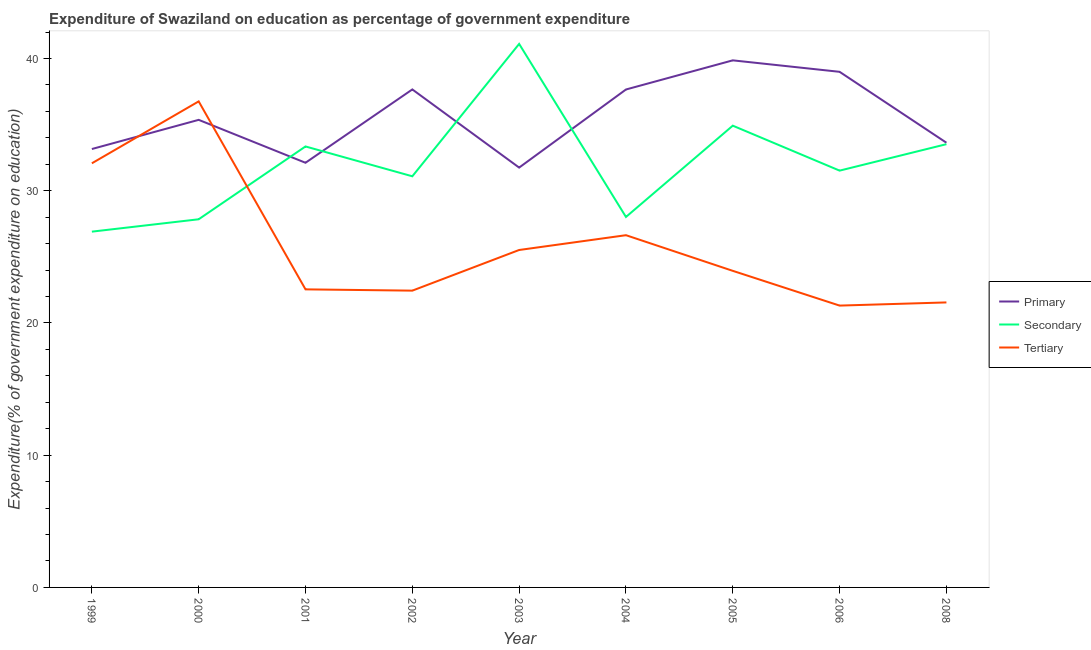What is the expenditure on secondary education in 2008?
Provide a short and direct response. 33.52. Across all years, what is the maximum expenditure on primary education?
Keep it short and to the point. 39.86. Across all years, what is the minimum expenditure on secondary education?
Your answer should be very brief. 26.9. In which year was the expenditure on tertiary education maximum?
Give a very brief answer. 2000. What is the total expenditure on primary education in the graph?
Your answer should be compact. 320.17. What is the difference between the expenditure on primary education in 2000 and that in 2005?
Provide a succinct answer. -4.5. What is the difference between the expenditure on tertiary education in 2008 and the expenditure on primary education in 2006?
Provide a succinct answer. -17.44. What is the average expenditure on secondary education per year?
Offer a very short reply. 32.03. In the year 1999, what is the difference between the expenditure on tertiary education and expenditure on secondary education?
Make the answer very short. 5.17. What is the ratio of the expenditure on secondary education in 2000 to that in 2006?
Offer a terse response. 0.88. What is the difference between the highest and the second highest expenditure on primary education?
Your answer should be compact. 0.87. What is the difference between the highest and the lowest expenditure on primary education?
Offer a terse response. 8.11. In how many years, is the expenditure on tertiary education greater than the average expenditure on tertiary education taken over all years?
Provide a short and direct response. 3. Is the sum of the expenditure on secondary education in 2005 and 2008 greater than the maximum expenditure on tertiary education across all years?
Make the answer very short. Yes. Does the expenditure on primary education monotonically increase over the years?
Your answer should be very brief. No. Is the expenditure on secondary education strictly less than the expenditure on primary education over the years?
Your answer should be very brief. No. How many years are there in the graph?
Keep it short and to the point. 9. Does the graph contain any zero values?
Provide a succinct answer. No. Does the graph contain grids?
Give a very brief answer. No. Where does the legend appear in the graph?
Give a very brief answer. Center right. How many legend labels are there?
Offer a terse response. 3. What is the title of the graph?
Your answer should be very brief. Expenditure of Swaziland on education as percentage of government expenditure. Does "Errors" appear as one of the legend labels in the graph?
Provide a short and direct response. No. What is the label or title of the Y-axis?
Offer a terse response. Expenditure(% of government expenditure on education). What is the Expenditure(% of government expenditure on education) in Primary in 1999?
Your answer should be very brief. 33.15. What is the Expenditure(% of government expenditure on education) of Secondary in 1999?
Make the answer very short. 26.9. What is the Expenditure(% of government expenditure on education) of Tertiary in 1999?
Provide a succinct answer. 32.07. What is the Expenditure(% of government expenditure on education) in Primary in 2000?
Your answer should be compact. 35.36. What is the Expenditure(% of government expenditure on education) in Secondary in 2000?
Your answer should be very brief. 27.84. What is the Expenditure(% of government expenditure on education) in Tertiary in 2000?
Offer a terse response. 36.76. What is the Expenditure(% of government expenditure on education) in Primary in 2001?
Your answer should be very brief. 32.11. What is the Expenditure(% of government expenditure on education) in Secondary in 2001?
Offer a very short reply. 33.35. What is the Expenditure(% of government expenditure on education) in Tertiary in 2001?
Provide a succinct answer. 22.54. What is the Expenditure(% of government expenditure on education) in Primary in 2002?
Your response must be concise. 37.66. What is the Expenditure(% of government expenditure on education) in Secondary in 2002?
Make the answer very short. 31.09. What is the Expenditure(% of government expenditure on education) in Tertiary in 2002?
Provide a short and direct response. 22.44. What is the Expenditure(% of government expenditure on education) in Primary in 2003?
Your response must be concise. 31.75. What is the Expenditure(% of government expenditure on education) of Secondary in 2003?
Offer a very short reply. 41.1. What is the Expenditure(% of government expenditure on education) of Tertiary in 2003?
Give a very brief answer. 25.52. What is the Expenditure(% of government expenditure on education) in Primary in 2004?
Provide a succinct answer. 37.66. What is the Expenditure(% of government expenditure on education) in Secondary in 2004?
Ensure brevity in your answer.  28.02. What is the Expenditure(% of government expenditure on education) of Tertiary in 2004?
Your answer should be very brief. 26.64. What is the Expenditure(% of government expenditure on education) in Primary in 2005?
Give a very brief answer. 39.86. What is the Expenditure(% of government expenditure on education) of Secondary in 2005?
Your answer should be very brief. 34.92. What is the Expenditure(% of government expenditure on education) of Tertiary in 2005?
Provide a short and direct response. 23.94. What is the Expenditure(% of government expenditure on education) of Primary in 2006?
Your answer should be compact. 38.99. What is the Expenditure(% of government expenditure on education) of Secondary in 2006?
Offer a very short reply. 31.52. What is the Expenditure(% of government expenditure on education) of Tertiary in 2006?
Provide a short and direct response. 21.31. What is the Expenditure(% of government expenditure on education) of Primary in 2008?
Give a very brief answer. 33.63. What is the Expenditure(% of government expenditure on education) of Secondary in 2008?
Offer a very short reply. 33.52. What is the Expenditure(% of government expenditure on education) in Tertiary in 2008?
Give a very brief answer. 21.55. Across all years, what is the maximum Expenditure(% of government expenditure on education) in Primary?
Your answer should be compact. 39.86. Across all years, what is the maximum Expenditure(% of government expenditure on education) of Secondary?
Keep it short and to the point. 41.1. Across all years, what is the maximum Expenditure(% of government expenditure on education) of Tertiary?
Give a very brief answer. 36.76. Across all years, what is the minimum Expenditure(% of government expenditure on education) of Primary?
Ensure brevity in your answer.  31.75. Across all years, what is the minimum Expenditure(% of government expenditure on education) in Secondary?
Ensure brevity in your answer.  26.9. Across all years, what is the minimum Expenditure(% of government expenditure on education) of Tertiary?
Offer a terse response. 21.31. What is the total Expenditure(% of government expenditure on education) of Primary in the graph?
Provide a succinct answer. 320.17. What is the total Expenditure(% of government expenditure on education) in Secondary in the graph?
Offer a very short reply. 288.26. What is the total Expenditure(% of government expenditure on education) of Tertiary in the graph?
Offer a very short reply. 232.77. What is the difference between the Expenditure(% of government expenditure on education) in Primary in 1999 and that in 2000?
Ensure brevity in your answer.  -2.21. What is the difference between the Expenditure(% of government expenditure on education) of Secondary in 1999 and that in 2000?
Your response must be concise. -0.94. What is the difference between the Expenditure(% of government expenditure on education) of Tertiary in 1999 and that in 2000?
Keep it short and to the point. -4.68. What is the difference between the Expenditure(% of government expenditure on education) of Primary in 1999 and that in 2001?
Keep it short and to the point. 1.04. What is the difference between the Expenditure(% of government expenditure on education) of Secondary in 1999 and that in 2001?
Keep it short and to the point. -6.44. What is the difference between the Expenditure(% of government expenditure on education) in Tertiary in 1999 and that in 2001?
Keep it short and to the point. 9.53. What is the difference between the Expenditure(% of government expenditure on education) of Primary in 1999 and that in 2002?
Provide a short and direct response. -4.51. What is the difference between the Expenditure(% of government expenditure on education) in Secondary in 1999 and that in 2002?
Give a very brief answer. -4.19. What is the difference between the Expenditure(% of government expenditure on education) in Tertiary in 1999 and that in 2002?
Give a very brief answer. 9.63. What is the difference between the Expenditure(% of government expenditure on education) of Primary in 1999 and that in 2003?
Your response must be concise. 1.4. What is the difference between the Expenditure(% of government expenditure on education) of Secondary in 1999 and that in 2003?
Ensure brevity in your answer.  -14.2. What is the difference between the Expenditure(% of government expenditure on education) of Tertiary in 1999 and that in 2003?
Give a very brief answer. 6.56. What is the difference between the Expenditure(% of government expenditure on education) in Primary in 1999 and that in 2004?
Make the answer very short. -4.5. What is the difference between the Expenditure(% of government expenditure on education) in Secondary in 1999 and that in 2004?
Offer a very short reply. -1.11. What is the difference between the Expenditure(% of government expenditure on education) in Tertiary in 1999 and that in 2004?
Give a very brief answer. 5.44. What is the difference between the Expenditure(% of government expenditure on education) of Primary in 1999 and that in 2005?
Your answer should be compact. -6.71. What is the difference between the Expenditure(% of government expenditure on education) of Secondary in 1999 and that in 2005?
Provide a succinct answer. -8.02. What is the difference between the Expenditure(% of government expenditure on education) of Tertiary in 1999 and that in 2005?
Provide a succinct answer. 8.13. What is the difference between the Expenditure(% of government expenditure on education) in Primary in 1999 and that in 2006?
Make the answer very short. -5.84. What is the difference between the Expenditure(% of government expenditure on education) in Secondary in 1999 and that in 2006?
Provide a short and direct response. -4.61. What is the difference between the Expenditure(% of government expenditure on education) of Tertiary in 1999 and that in 2006?
Give a very brief answer. 10.76. What is the difference between the Expenditure(% of government expenditure on education) in Primary in 1999 and that in 2008?
Provide a short and direct response. -0.48. What is the difference between the Expenditure(% of government expenditure on education) in Secondary in 1999 and that in 2008?
Your answer should be compact. -6.62. What is the difference between the Expenditure(% of government expenditure on education) in Tertiary in 1999 and that in 2008?
Ensure brevity in your answer.  10.52. What is the difference between the Expenditure(% of government expenditure on education) in Primary in 2000 and that in 2001?
Keep it short and to the point. 3.25. What is the difference between the Expenditure(% of government expenditure on education) in Secondary in 2000 and that in 2001?
Your answer should be compact. -5.51. What is the difference between the Expenditure(% of government expenditure on education) of Tertiary in 2000 and that in 2001?
Your answer should be compact. 14.21. What is the difference between the Expenditure(% of government expenditure on education) in Primary in 2000 and that in 2002?
Your response must be concise. -2.3. What is the difference between the Expenditure(% of government expenditure on education) of Secondary in 2000 and that in 2002?
Your response must be concise. -3.25. What is the difference between the Expenditure(% of government expenditure on education) in Tertiary in 2000 and that in 2002?
Your answer should be very brief. 14.31. What is the difference between the Expenditure(% of government expenditure on education) in Primary in 2000 and that in 2003?
Ensure brevity in your answer.  3.61. What is the difference between the Expenditure(% of government expenditure on education) in Secondary in 2000 and that in 2003?
Your answer should be very brief. -13.26. What is the difference between the Expenditure(% of government expenditure on education) of Tertiary in 2000 and that in 2003?
Offer a very short reply. 11.24. What is the difference between the Expenditure(% of government expenditure on education) in Primary in 2000 and that in 2004?
Your answer should be compact. -2.3. What is the difference between the Expenditure(% of government expenditure on education) of Secondary in 2000 and that in 2004?
Give a very brief answer. -0.17. What is the difference between the Expenditure(% of government expenditure on education) of Tertiary in 2000 and that in 2004?
Keep it short and to the point. 10.12. What is the difference between the Expenditure(% of government expenditure on education) of Secondary in 2000 and that in 2005?
Your answer should be very brief. -7.08. What is the difference between the Expenditure(% of government expenditure on education) of Tertiary in 2000 and that in 2005?
Make the answer very short. 12.82. What is the difference between the Expenditure(% of government expenditure on education) of Primary in 2000 and that in 2006?
Provide a succinct answer. -3.63. What is the difference between the Expenditure(% of government expenditure on education) in Secondary in 2000 and that in 2006?
Ensure brevity in your answer.  -3.68. What is the difference between the Expenditure(% of government expenditure on education) of Tertiary in 2000 and that in 2006?
Offer a terse response. 15.44. What is the difference between the Expenditure(% of government expenditure on education) of Primary in 2000 and that in 2008?
Offer a very short reply. 1.73. What is the difference between the Expenditure(% of government expenditure on education) in Secondary in 2000 and that in 2008?
Provide a succinct answer. -5.68. What is the difference between the Expenditure(% of government expenditure on education) in Tertiary in 2000 and that in 2008?
Provide a short and direct response. 15.2. What is the difference between the Expenditure(% of government expenditure on education) of Primary in 2001 and that in 2002?
Provide a succinct answer. -5.55. What is the difference between the Expenditure(% of government expenditure on education) of Secondary in 2001 and that in 2002?
Your response must be concise. 2.26. What is the difference between the Expenditure(% of government expenditure on education) in Tertiary in 2001 and that in 2002?
Make the answer very short. 0.1. What is the difference between the Expenditure(% of government expenditure on education) of Primary in 2001 and that in 2003?
Offer a very short reply. 0.36. What is the difference between the Expenditure(% of government expenditure on education) in Secondary in 2001 and that in 2003?
Give a very brief answer. -7.75. What is the difference between the Expenditure(% of government expenditure on education) in Tertiary in 2001 and that in 2003?
Your response must be concise. -2.98. What is the difference between the Expenditure(% of government expenditure on education) in Primary in 2001 and that in 2004?
Ensure brevity in your answer.  -5.54. What is the difference between the Expenditure(% of government expenditure on education) in Secondary in 2001 and that in 2004?
Provide a succinct answer. 5.33. What is the difference between the Expenditure(% of government expenditure on education) of Tertiary in 2001 and that in 2004?
Your answer should be very brief. -4.1. What is the difference between the Expenditure(% of government expenditure on education) of Primary in 2001 and that in 2005?
Your answer should be compact. -7.75. What is the difference between the Expenditure(% of government expenditure on education) of Secondary in 2001 and that in 2005?
Provide a succinct answer. -1.57. What is the difference between the Expenditure(% of government expenditure on education) of Tertiary in 2001 and that in 2005?
Offer a terse response. -1.4. What is the difference between the Expenditure(% of government expenditure on education) of Primary in 2001 and that in 2006?
Ensure brevity in your answer.  -6.88. What is the difference between the Expenditure(% of government expenditure on education) of Secondary in 2001 and that in 2006?
Ensure brevity in your answer.  1.83. What is the difference between the Expenditure(% of government expenditure on education) in Tertiary in 2001 and that in 2006?
Provide a succinct answer. 1.23. What is the difference between the Expenditure(% of government expenditure on education) in Primary in 2001 and that in 2008?
Your response must be concise. -1.52. What is the difference between the Expenditure(% of government expenditure on education) in Secondary in 2001 and that in 2008?
Make the answer very short. -0.17. What is the difference between the Expenditure(% of government expenditure on education) in Tertiary in 2001 and that in 2008?
Offer a very short reply. 0.99. What is the difference between the Expenditure(% of government expenditure on education) of Primary in 2002 and that in 2003?
Ensure brevity in your answer.  5.91. What is the difference between the Expenditure(% of government expenditure on education) in Secondary in 2002 and that in 2003?
Your response must be concise. -10.01. What is the difference between the Expenditure(% of government expenditure on education) in Tertiary in 2002 and that in 2003?
Offer a very short reply. -3.07. What is the difference between the Expenditure(% of government expenditure on education) of Primary in 2002 and that in 2004?
Offer a terse response. 0. What is the difference between the Expenditure(% of government expenditure on education) in Secondary in 2002 and that in 2004?
Give a very brief answer. 3.08. What is the difference between the Expenditure(% of government expenditure on education) in Tertiary in 2002 and that in 2004?
Keep it short and to the point. -4.19. What is the difference between the Expenditure(% of government expenditure on education) in Primary in 2002 and that in 2005?
Offer a very short reply. -2.2. What is the difference between the Expenditure(% of government expenditure on education) of Secondary in 2002 and that in 2005?
Offer a very short reply. -3.83. What is the difference between the Expenditure(% of government expenditure on education) of Tertiary in 2002 and that in 2005?
Your answer should be very brief. -1.5. What is the difference between the Expenditure(% of government expenditure on education) of Primary in 2002 and that in 2006?
Provide a succinct answer. -1.33. What is the difference between the Expenditure(% of government expenditure on education) of Secondary in 2002 and that in 2006?
Give a very brief answer. -0.43. What is the difference between the Expenditure(% of government expenditure on education) of Tertiary in 2002 and that in 2006?
Provide a succinct answer. 1.13. What is the difference between the Expenditure(% of government expenditure on education) in Primary in 2002 and that in 2008?
Offer a terse response. 4.03. What is the difference between the Expenditure(% of government expenditure on education) of Secondary in 2002 and that in 2008?
Provide a short and direct response. -2.43. What is the difference between the Expenditure(% of government expenditure on education) of Tertiary in 2002 and that in 2008?
Provide a succinct answer. 0.89. What is the difference between the Expenditure(% of government expenditure on education) of Primary in 2003 and that in 2004?
Provide a short and direct response. -5.91. What is the difference between the Expenditure(% of government expenditure on education) in Secondary in 2003 and that in 2004?
Your response must be concise. 13.09. What is the difference between the Expenditure(% of government expenditure on education) of Tertiary in 2003 and that in 2004?
Give a very brief answer. -1.12. What is the difference between the Expenditure(% of government expenditure on education) of Primary in 2003 and that in 2005?
Make the answer very short. -8.11. What is the difference between the Expenditure(% of government expenditure on education) of Secondary in 2003 and that in 2005?
Provide a succinct answer. 6.18. What is the difference between the Expenditure(% of government expenditure on education) in Tertiary in 2003 and that in 2005?
Your answer should be very brief. 1.58. What is the difference between the Expenditure(% of government expenditure on education) of Primary in 2003 and that in 2006?
Offer a terse response. -7.24. What is the difference between the Expenditure(% of government expenditure on education) in Secondary in 2003 and that in 2006?
Your answer should be compact. 9.58. What is the difference between the Expenditure(% of government expenditure on education) in Tertiary in 2003 and that in 2006?
Offer a terse response. 4.21. What is the difference between the Expenditure(% of government expenditure on education) in Primary in 2003 and that in 2008?
Provide a short and direct response. -1.88. What is the difference between the Expenditure(% of government expenditure on education) of Secondary in 2003 and that in 2008?
Ensure brevity in your answer.  7.58. What is the difference between the Expenditure(% of government expenditure on education) in Tertiary in 2003 and that in 2008?
Your answer should be very brief. 3.97. What is the difference between the Expenditure(% of government expenditure on education) in Primary in 2004 and that in 2005?
Make the answer very short. -2.2. What is the difference between the Expenditure(% of government expenditure on education) in Secondary in 2004 and that in 2005?
Your response must be concise. -6.9. What is the difference between the Expenditure(% of government expenditure on education) in Tertiary in 2004 and that in 2005?
Offer a terse response. 2.7. What is the difference between the Expenditure(% of government expenditure on education) in Primary in 2004 and that in 2006?
Offer a very short reply. -1.34. What is the difference between the Expenditure(% of government expenditure on education) in Secondary in 2004 and that in 2006?
Your answer should be very brief. -3.5. What is the difference between the Expenditure(% of government expenditure on education) of Tertiary in 2004 and that in 2006?
Keep it short and to the point. 5.32. What is the difference between the Expenditure(% of government expenditure on education) of Primary in 2004 and that in 2008?
Make the answer very short. 4.03. What is the difference between the Expenditure(% of government expenditure on education) in Secondary in 2004 and that in 2008?
Provide a succinct answer. -5.5. What is the difference between the Expenditure(% of government expenditure on education) of Tertiary in 2004 and that in 2008?
Provide a succinct answer. 5.08. What is the difference between the Expenditure(% of government expenditure on education) of Primary in 2005 and that in 2006?
Ensure brevity in your answer.  0.87. What is the difference between the Expenditure(% of government expenditure on education) in Secondary in 2005 and that in 2006?
Provide a succinct answer. 3.4. What is the difference between the Expenditure(% of government expenditure on education) in Tertiary in 2005 and that in 2006?
Ensure brevity in your answer.  2.63. What is the difference between the Expenditure(% of government expenditure on education) of Primary in 2005 and that in 2008?
Give a very brief answer. 6.23. What is the difference between the Expenditure(% of government expenditure on education) of Secondary in 2005 and that in 2008?
Keep it short and to the point. 1.4. What is the difference between the Expenditure(% of government expenditure on education) in Tertiary in 2005 and that in 2008?
Provide a short and direct response. 2.39. What is the difference between the Expenditure(% of government expenditure on education) of Primary in 2006 and that in 2008?
Make the answer very short. 5.36. What is the difference between the Expenditure(% of government expenditure on education) in Secondary in 2006 and that in 2008?
Provide a succinct answer. -2. What is the difference between the Expenditure(% of government expenditure on education) of Tertiary in 2006 and that in 2008?
Ensure brevity in your answer.  -0.24. What is the difference between the Expenditure(% of government expenditure on education) in Primary in 1999 and the Expenditure(% of government expenditure on education) in Secondary in 2000?
Provide a succinct answer. 5.31. What is the difference between the Expenditure(% of government expenditure on education) in Primary in 1999 and the Expenditure(% of government expenditure on education) in Tertiary in 2000?
Offer a very short reply. -3.6. What is the difference between the Expenditure(% of government expenditure on education) of Secondary in 1999 and the Expenditure(% of government expenditure on education) of Tertiary in 2000?
Provide a succinct answer. -9.85. What is the difference between the Expenditure(% of government expenditure on education) of Primary in 1999 and the Expenditure(% of government expenditure on education) of Secondary in 2001?
Provide a short and direct response. -0.19. What is the difference between the Expenditure(% of government expenditure on education) of Primary in 1999 and the Expenditure(% of government expenditure on education) of Tertiary in 2001?
Offer a terse response. 10.61. What is the difference between the Expenditure(% of government expenditure on education) of Secondary in 1999 and the Expenditure(% of government expenditure on education) of Tertiary in 2001?
Give a very brief answer. 4.36. What is the difference between the Expenditure(% of government expenditure on education) of Primary in 1999 and the Expenditure(% of government expenditure on education) of Secondary in 2002?
Keep it short and to the point. 2.06. What is the difference between the Expenditure(% of government expenditure on education) of Primary in 1999 and the Expenditure(% of government expenditure on education) of Tertiary in 2002?
Your response must be concise. 10.71. What is the difference between the Expenditure(% of government expenditure on education) in Secondary in 1999 and the Expenditure(% of government expenditure on education) in Tertiary in 2002?
Give a very brief answer. 4.46. What is the difference between the Expenditure(% of government expenditure on education) of Primary in 1999 and the Expenditure(% of government expenditure on education) of Secondary in 2003?
Make the answer very short. -7.95. What is the difference between the Expenditure(% of government expenditure on education) of Primary in 1999 and the Expenditure(% of government expenditure on education) of Tertiary in 2003?
Provide a succinct answer. 7.64. What is the difference between the Expenditure(% of government expenditure on education) in Secondary in 1999 and the Expenditure(% of government expenditure on education) in Tertiary in 2003?
Your answer should be compact. 1.39. What is the difference between the Expenditure(% of government expenditure on education) of Primary in 1999 and the Expenditure(% of government expenditure on education) of Secondary in 2004?
Ensure brevity in your answer.  5.14. What is the difference between the Expenditure(% of government expenditure on education) in Primary in 1999 and the Expenditure(% of government expenditure on education) in Tertiary in 2004?
Give a very brief answer. 6.52. What is the difference between the Expenditure(% of government expenditure on education) in Secondary in 1999 and the Expenditure(% of government expenditure on education) in Tertiary in 2004?
Your answer should be very brief. 0.27. What is the difference between the Expenditure(% of government expenditure on education) of Primary in 1999 and the Expenditure(% of government expenditure on education) of Secondary in 2005?
Offer a terse response. -1.77. What is the difference between the Expenditure(% of government expenditure on education) in Primary in 1999 and the Expenditure(% of government expenditure on education) in Tertiary in 2005?
Keep it short and to the point. 9.21. What is the difference between the Expenditure(% of government expenditure on education) of Secondary in 1999 and the Expenditure(% of government expenditure on education) of Tertiary in 2005?
Give a very brief answer. 2.96. What is the difference between the Expenditure(% of government expenditure on education) of Primary in 1999 and the Expenditure(% of government expenditure on education) of Secondary in 2006?
Give a very brief answer. 1.63. What is the difference between the Expenditure(% of government expenditure on education) in Primary in 1999 and the Expenditure(% of government expenditure on education) in Tertiary in 2006?
Your answer should be very brief. 11.84. What is the difference between the Expenditure(% of government expenditure on education) of Secondary in 1999 and the Expenditure(% of government expenditure on education) of Tertiary in 2006?
Ensure brevity in your answer.  5.59. What is the difference between the Expenditure(% of government expenditure on education) of Primary in 1999 and the Expenditure(% of government expenditure on education) of Secondary in 2008?
Your answer should be compact. -0.37. What is the difference between the Expenditure(% of government expenditure on education) in Primary in 1999 and the Expenditure(% of government expenditure on education) in Tertiary in 2008?
Your response must be concise. 11.6. What is the difference between the Expenditure(% of government expenditure on education) of Secondary in 1999 and the Expenditure(% of government expenditure on education) of Tertiary in 2008?
Keep it short and to the point. 5.35. What is the difference between the Expenditure(% of government expenditure on education) in Primary in 2000 and the Expenditure(% of government expenditure on education) in Secondary in 2001?
Keep it short and to the point. 2.01. What is the difference between the Expenditure(% of government expenditure on education) of Primary in 2000 and the Expenditure(% of government expenditure on education) of Tertiary in 2001?
Your answer should be very brief. 12.82. What is the difference between the Expenditure(% of government expenditure on education) in Secondary in 2000 and the Expenditure(% of government expenditure on education) in Tertiary in 2001?
Keep it short and to the point. 5.3. What is the difference between the Expenditure(% of government expenditure on education) of Primary in 2000 and the Expenditure(% of government expenditure on education) of Secondary in 2002?
Keep it short and to the point. 4.27. What is the difference between the Expenditure(% of government expenditure on education) in Primary in 2000 and the Expenditure(% of government expenditure on education) in Tertiary in 2002?
Your answer should be compact. 12.92. What is the difference between the Expenditure(% of government expenditure on education) in Secondary in 2000 and the Expenditure(% of government expenditure on education) in Tertiary in 2002?
Give a very brief answer. 5.4. What is the difference between the Expenditure(% of government expenditure on education) of Primary in 2000 and the Expenditure(% of government expenditure on education) of Secondary in 2003?
Ensure brevity in your answer.  -5.74. What is the difference between the Expenditure(% of government expenditure on education) in Primary in 2000 and the Expenditure(% of government expenditure on education) in Tertiary in 2003?
Offer a very short reply. 9.84. What is the difference between the Expenditure(% of government expenditure on education) of Secondary in 2000 and the Expenditure(% of government expenditure on education) of Tertiary in 2003?
Offer a terse response. 2.32. What is the difference between the Expenditure(% of government expenditure on education) in Primary in 2000 and the Expenditure(% of government expenditure on education) in Secondary in 2004?
Ensure brevity in your answer.  7.34. What is the difference between the Expenditure(% of government expenditure on education) of Primary in 2000 and the Expenditure(% of government expenditure on education) of Tertiary in 2004?
Give a very brief answer. 8.72. What is the difference between the Expenditure(% of government expenditure on education) of Secondary in 2000 and the Expenditure(% of government expenditure on education) of Tertiary in 2004?
Offer a terse response. 1.2. What is the difference between the Expenditure(% of government expenditure on education) in Primary in 2000 and the Expenditure(% of government expenditure on education) in Secondary in 2005?
Your answer should be very brief. 0.44. What is the difference between the Expenditure(% of government expenditure on education) of Primary in 2000 and the Expenditure(% of government expenditure on education) of Tertiary in 2005?
Offer a terse response. 11.42. What is the difference between the Expenditure(% of government expenditure on education) of Secondary in 2000 and the Expenditure(% of government expenditure on education) of Tertiary in 2005?
Ensure brevity in your answer.  3.9. What is the difference between the Expenditure(% of government expenditure on education) of Primary in 2000 and the Expenditure(% of government expenditure on education) of Secondary in 2006?
Your response must be concise. 3.84. What is the difference between the Expenditure(% of government expenditure on education) in Primary in 2000 and the Expenditure(% of government expenditure on education) in Tertiary in 2006?
Your answer should be very brief. 14.05. What is the difference between the Expenditure(% of government expenditure on education) of Secondary in 2000 and the Expenditure(% of government expenditure on education) of Tertiary in 2006?
Provide a succinct answer. 6.53. What is the difference between the Expenditure(% of government expenditure on education) of Primary in 2000 and the Expenditure(% of government expenditure on education) of Secondary in 2008?
Make the answer very short. 1.84. What is the difference between the Expenditure(% of government expenditure on education) in Primary in 2000 and the Expenditure(% of government expenditure on education) in Tertiary in 2008?
Your answer should be compact. 13.81. What is the difference between the Expenditure(% of government expenditure on education) in Secondary in 2000 and the Expenditure(% of government expenditure on education) in Tertiary in 2008?
Ensure brevity in your answer.  6.29. What is the difference between the Expenditure(% of government expenditure on education) of Primary in 2001 and the Expenditure(% of government expenditure on education) of Secondary in 2002?
Offer a very short reply. 1.02. What is the difference between the Expenditure(% of government expenditure on education) in Primary in 2001 and the Expenditure(% of government expenditure on education) in Tertiary in 2002?
Provide a short and direct response. 9.67. What is the difference between the Expenditure(% of government expenditure on education) of Secondary in 2001 and the Expenditure(% of government expenditure on education) of Tertiary in 2002?
Make the answer very short. 10.9. What is the difference between the Expenditure(% of government expenditure on education) in Primary in 2001 and the Expenditure(% of government expenditure on education) in Secondary in 2003?
Your response must be concise. -8.99. What is the difference between the Expenditure(% of government expenditure on education) of Primary in 2001 and the Expenditure(% of government expenditure on education) of Tertiary in 2003?
Give a very brief answer. 6.6. What is the difference between the Expenditure(% of government expenditure on education) of Secondary in 2001 and the Expenditure(% of government expenditure on education) of Tertiary in 2003?
Your response must be concise. 7.83. What is the difference between the Expenditure(% of government expenditure on education) of Primary in 2001 and the Expenditure(% of government expenditure on education) of Secondary in 2004?
Make the answer very short. 4.1. What is the difference between the Expenditure(% of government expenditure on education) in Primary in 2001 and the Expenditure(% of government expenditure on education) in Tertiary in 2004?
Give a very brief answer. 5.48. What is the difference between the Expenditure(% of government expenditure on education) in Secondary in 2001 and the Expenditure(% of government expenditure on education) in Tertiary in 2004?
Ensure brevity in your answer.  6.71. What is the difference between the Expenditure(% of government expenditure on education) in Primary in 2001 and the Expenditure(% of government expenditure on education) in Secondary in 2005?
Make the answer very short. -2.81. What is the difference between the Expenditure(% of government expenditure on education) of Primary in 2001 and the Expenditure(% of government expenditure on education) of Tertiary in 2005?
Your answer should be compact. 8.17. What is the difference between the Expenditure(% of government expenditure on education) of Secondary in 2001 and the Expenditure(% of government expenditure on education) of Tertiary in 2005?
Provide a succinct answer. 9.41. What is the difference between the Expenditure(% of government expenditure on education) in Primary in 2001 and the Expenditure(% of government expenditure on education) in Secondary in 2006?
Give a very brief answer. 0.59. What is the difference between the Expenditure(% of government expenditure on education) of Primary in 2001 and the Expenditure(% of government expenditure on education) of Tertiary in 2006?
Your answer should be very brief. 10.8. What is the difference between the Expenditure(% of government expenditure on education) in Secondary in 2001 and the Expenditure(% of government expenditure on education) in Tertiary in 2006?
Offer a terse response. 12.03. What is the difference between the Expenditure(% of government expenditure on education) of Primary in 2001 and the Expenditure(% of government expenditure on education) of Secondary in 2008?
Ensure brevity in your answer.  -1.41. What is the difference between the Expenditure(% of government expenditure on education) in Primary in 2001 and the Expenditure(% of government expenditure on education) in Tertiary in 2008?
Make the answer very short. 10.56. What is the difference between the Expenditure(% of government expenditure on education) of Secondary in 2001 and the Expenditure(% of government expenditure on education) of Tertiary in 2008?
Your response must be concise. 11.79. What is the difference between the Expenditure(% of government expenditure on education) of Primary in 2002 and the Expenditure(% of government expenditure on education) of Secondary in 2003?
Give a very brief answer. -3.44. What is the difference between the Expenditure(% of government expenditure on education) of Primary in 2002 and the Expenditure(% of government expenditure on education) of Tertiary in 2003?
Keep it short and to the point. 12.14. What is the difference between the Expenditure(% of government expenditure on education) in Secondary in 2002 and the Expenditure(% of government expenditure on education) in Tertiary in 2003?
Give a very brief answer. 5.57. What is the difference between the Expenditure(% of government expenditure on education) of Primary in 2002 and the Expenditure(% of government expenditure on education) of Secondary in 2004?
Your response must be concise. 9.64. What is the difference between the Expenditure(% of government expenditure on education) in Primary in 2002 and the Expenditure(% of government expenditure on education) in Tertiary in 2004?
Give a very brief answer. 11.02. What is the difference between the Expenditure(% of government expenditure on education) of Secondary in 2002 and the Expenditure(% of government expenditure on education) of Tertiary in 2004?
Your response must be concise. 4.46. What is the difference between the Expenditure(% of government expenditure on education) of Primary in 2002 and the Expenditure(% of government expenditure on education) of Secondary in 2005?
Give a very brief answer. 2.74. What is the difference between the Expenditure(% of government expenditure on education) of Primary in 2002 and the Expenditure(% of government expenditure on education) of Tertiary in 2005?
Offer a very short reply. 13.72. What is the difference between the Expenditure(% of government expenditure on education) in Secondary in 2002 and the Expenditure(% of government expenditure on education) in Tertiary in 2005?
Give a very brief answer. 7.15. What is the difference between the Expenditure(% of government expenditure on education) in Primary in 2002 and the Expenditure(% of government expenditure on education) in Secondary in 2006?
Your answer should be compact. 6.14. What is the difference between the Expenditure(% of government expenditure on education) of Primary in 2002 and the Expenditure(% of government expenditure on education) of Tertiary in 2006?
Give a very brief answer. 16.35. What is the difference between the Expenditure(% of government expenditure on education) in Secondary in 2002 and the Expenditure(% of government expenditure on education) in Tertiary in 2006?
Make the answer very short. 9.78. What is the difference between the Expenditure(% of government expenditure on education) in Primary in 2002 and the Expenditure(% of government expenditure on education) in Secondary in 2008?
Provide a succinct answer. 4.14. What is the difference between the Expenditure(% of government expenditure on education) in Primary in 2002 and the Expenditure(% of government expenditure on education) in Tertiary in 2008?
Give a very brief answer. 16.11. What is the difference between the Expenditure(% of government expenditure on education) of Secondary in 2002 and the Expenditure(% of government expenditure on education) of Tertiary in 2008?
Offer a terse response. 9.54. What is the difference between the Expenditure(% of government expenditure on education) of Primary in 2003 and the Expenditure(% of government expenditure on education) of Secondary in 2004?
Keep it short and to the point. 3.73. What is the difference between the Expenditure(% of government expenditure on education) of Primary in 2003 and the Expenditure(% of government expenditure on education) of Tertiary in 2004?
Your answer should be very brief. 5.11. What is the difference between the Expenditure(% of government expenditure on education) of Secondary in 2003 and the Expenditure(% of government expenditure on education) of Tertiary in 2004?
Give a very brief answer. 14.47. What is the difference between the Expenditure(% of government expenditure on education) of Primary in 2003 and the Expenditure(% of government expenditure on education) of Secondary in 2005?
Give a very brief answer. -3.17. What is the difference between the Expenditure(% of government expenditure on education) in Primary in 2003 and the Expenditure(% of government expenditure on education) in Tertiary in 2005?
Make the answer very short. 7.81. What is the difference between the Expenditure(% of government expenditure on education) of Secondary in 2003 and the Expenditure(% of government expenditure on education) of Tertiary in 2005?
Make the answer very short. 17.16. What is the difference between the Expenditure(% of government expenditure on education) in Primary in 2003 and the Expenditure(% of government expenditure on education) in Secondary in 2006?
Offer a terse response. 0.23. What is the difference between the Expenditure(% of government expenditure on education) of Primary in 2003 and the Expenditure(% of government expenditure on education) of Tertiary in 2006?
Your response must be concise. 10.44. What is the difference between the Expenditure(% of government expenditure on education) in Secondary in 2003 and the Expenditure(% of government expenditure on education) in Tertiary in 2006?
Provide a succinct answer. 19.79. What is the difference between the Expenditure(% of government expenditure on education) of Primary in 2003 and the Expenditure(% of government expenditure on education) of Secondary in 2008?
Provide a succinct answer. -1.77. What is the difference between the Expenditure(% of government expenditure on education) of Primary in 2003 and the Expenditure(% of government expenditure on education) of Tertiary in 2008?
Give a very brief answer. 10.2. What is the difference between the Expenditure(% of government expenditure on education) in Secondary in 2003 and the Expenditure(% of government expenditure on education) in Tertiary in 2008?
Give a very brief answer. 19.55. What is the difference between the Expenditure(% of government expenditure on education) of Primary in 2004 and the Expenditure(% of government expenditure on education) of Secondary in 2005?
Your answer should be compact. 2.74. What is the difference between the Expenditure(% of government expenditure on education) in Primary in 2004 and the Expenditure(% of government expenditure on education) in Tertiary in 2005?
Keep it short and to the point. 13.71. What is the difference between the Expenditure(% of government expenditure on education) of Secondary in 2004 and the Expenditure(% of government expenditure on education) of Tertiary in 2005?
Your answer should be compact. 4.08. What is the difference between the Expenditure(% of government expenditure on education) in Primary in 2004 and the Expenditure(% of government expenditure on education) in Secondary in 2006?
Make the answer very short. 6.14. What is the difference between the Expenditure(% of government expenditure on education) in Primary in 2004 and the Expenditure(% of government expenditure on education) in Tertiary in 2006?
Your answer should be very brief. 16.34. What is the difference between the Expenditure(% of government expenditure on education) of Secondary in 2004 and the Expenditure(% of government expenditure on education) of Tertiary in 2006?
Ensure brevity in your answer.  6.7. What is the difference between the Expenditure(% of government expenditure on education) of Primary in 2004 and the Expenditure(% of government expenditure on education) of Secondary in 2008?
Your answer should be very brief. 4.14. What is the difference between the Expenditure(% of government expenditure on education) in Primary in 2004 and the Expenditure(% of government expenditure on education) in Tertiary in 2008?
Your answer should be very brief. 16.1. What is the difference between the Expenditure(% of government expenditure on education) in Secondary in 2004 and the Expenditure(% of government expenditure on education) in Tertiary in 2008?
Offer a terse response. 6.46. What is the difference between the Expenditure(% of government expenditure on education) in Primary in 2005 and the Expenditure(% of government expenditure on education) in Secondary in 2006?
Ensure brevity in your answer.  8.34. What is the difference between the Expenditure(% of government expenditure on education) in Primary in 2005 and the Expenditure(% of government expenditure on education) in Tertiary in 2006?
Your answer should be compact. 18.55. What is the difference between the Expenditure(% of government expenditure on education) of Secondary in 2005 and the Expenditure(% of government expenditure on education) of Tertiary in 2006?
Keep it short and to the point. 13.61. What is the difference between the Expenditure(% of government expenditure on education) in Primary in 2005 and the Expenditure(% of government expenditure on education) in Secondary in 2008?
Keep it short and to the point. 6.34. What is the difference between the Expenditure(% of government expenditure on education) in Primary in 2005 and the Expenditure(% of government expenditure on education) in Tertiary in 2008?
Keep it short and to the point. 18.31. What is the difference between the Expenditure(% of government expenditure on education) in Secondary in 2005 and the Expenditure(% of government expenditure on education) in Tertiary in 2008?
Your answer should be compact. 13.37. What is the difference between the Expenditure(% of government expenditure on education) in Primary in 2006 and the Expenditure(% of government expenditure on education) in Secondary in 2008?
Your answer should be compact. 5.47. What is the difference between the Expenditure(% of government expenditure on education) of Primary in 2006 and the Expenditure(% of government expenditure on education) of Tertiary in 2008?
Offer a terse response. 17.44. What is the difference between the Expenditure(% of government expenditure on education) of Secondary in 2006 and the Expenditure(% of government expenditure on education) of Tertiary in 2008?
Your answer should be compact. 9.97. What is the average Expenditure(% of government expenditure on education) of Primary per year?
Provide a succinct answer. 35.57. What is the average Expenditure(% of government expenditure on education) of Secondary per year?
Keep it short and to the point. 32.03. What is the average Expenditure(% of government expenditure on education) of Tertiary per year?
Your response must be concise. 25.86. In the year 1999, what is the difference between the Expenditure(% of government expenditure on education) of Primary and Expenditure(% of government expenditure on education) of Secondary?
Make the answer very short. 6.25. In the year 1999, what is the difference between the Expenditure(% of government expenditure on education) of Primary and Expenditure(% of government expenditure on education) of Tertiary?
Your answer should be compact. 1.08. In the year 1999, what is the difference between the Expenditure(% of government expenditure on education) in Secondary and Expenditure(% of government expenditure on education) in Tertiary?
Your answer should be very brief. -5.17. In the year 2000, what is the difference between the Expenditure(% of government expenditure on education) in Primary and Expenditure(% of government expenditure on education) in Secondary?
Your answer should be compact. 7.52. In the year 2000, what is the difference between the Expenditure(% of government expenditure on education) in Primary and Expenditure(% of government expenditure on education) in Tertiary?
Offer a very short reply. -1.4. In the year 2000, what is the difference between the Expenditure(% of government expenditure on education) of Secondary and Expenditure(% of government expenditure on education) of Tertiary?
Offer a very short reply. -8.91. In the year 2001, what is the difference between the Expenditure(% of government expenditure on education) of Primary and Expenditure(% of government expenditure on education) of Secondary?
Provide a short and direct response. -1.23. In the year 2001, what is the difference between the Expenditure(% of government expenditure on education) in Primary and Expenditure(% of government expenditure on education) in Tertiary?
Keep it short and to the point. 9.57. In the year 2001, what is the difference between the Expenditure(% of government expenditure on education) in Secondary and Expenditure(% of government expenditure on education) in Tertiary?
Your answer should be compact. 10.81. In the year 2002, what is the difference between the Expenditure(% of government expenditure on education) of Primary and Expenditure(% of government expenditure on education) of Secondary?
Make the answer very short. 6.57. In the year 2002, what is the difference between the Expenditure(% of government expenditure on education) in Primary and Expenditure(% of government expenditure on education) in Tertiary?
Provide a short and direct response. 15.22. In the year 2002, what is the difference between the Expenditure(% of government expenditure on education) in Secondary and Expenditure(% of government expenditure on education) in Tertiary?
Make the answer very short. 8.65. In the year 2003, what is the difference between the Expenditure(% of government expenditure on education) of Primary and Expenditure(% of government expenditure on education) of Secondary?
Keep it short and to the point. -9.35. In the year 2003, what is the difference between the Expenditure(% of government expenditure on education) in Primary and Expenditure(% of government expenditure on education) in Tertiary?
Provide a succinct answer. 6.23. In the year 2003, what is the difference between the Expenditure(% of government expenditure on education) in Secondary and Expenditure(% of government expenditure on education) in Tertiary?
Offer a very short reply. 15.58. In the year 2004, what is the difference between the Expenditure(% of government expenditure on education) of Primary and Expenditure(% of government expenditure on education) of Secondary?
Ensure brevity in your answer.  9.64. In the year 2004, what is the difference between the Expenditure(% of government expenditure on education) of Primary and Expenditure(% of government expenditure on education) of Tertiary?
Provide a succinct answer. 11.02. In the year 2004, what is the difference between the Expenditure(% of government expenditure on education) of Secondary and Expenditure(% of government expenditure on education) of Tertiary?
Ensure brevity in your answer.  1.38. In the year 2005, what is the difference between the Expenditure(% of government expenditure on education) of Primary and Expenditure(% of government expenditure on education) of Secondary?
Your answer should be compact. 4.94. In the year 2005, what is the difference between the Expenditure(% of government expenditure on education) in Primary and Expenditure(% of government expenditure on education) in Tertiary?
Offer a very short reply. 15.92. In the year 2005, what is the difference between the Expenditure(% of government expenditure on education) of Secondary and Expenditure(% of government expenditure on education) of Tertiary?
Keep it short and to the point. 10.98. In the year 2006, what is the difference between the Expenditure(% of government expenditure on education) of Primary and Expenditure(% of government expenditure on education) of Secondary?
Ensure brevity in your answer.  7.47. In the year 2006, what is the difference between the Expenditure(% of government expenditure on education) of Primary and Expenditure(% of government expenditure on education) of Tertiary?
Provide a succinct answer. 17.68. In the year 2006, what is the difference between the Expenditure(% of government expenditure on education) of Secondary and Expenditure(% of government expenditure on education) of Tertiary?
Offer a terse response. 10.21. In the year 2008, what is the difference between the Expenditure(% of government expenditure on education) of Primary and Expenditure(% of government expenditure on education) of Secondary?
Make the answer very short. 0.11. In the year 2008, what is the difference between the Expenditure(% of government expenditure on education) in Primary and Expenditure(% of government expenditure on education) in Tertiary?
Make the answer very short. 12.08. In the year 2008, what is the difference between the Expenditure(% of government expenditure on education) in Secondary and Expenditure(% of government expenditure on education) in Tertiary?
Provide a short and direct response. 11.97. What is the ratio of the Expenditure(% of government expenditure on education) in Primary in 1999 to that in 2000?
Your answer should be compact. 0.94. What is the ratio of the Expenditure(% of government expenditure on education) in Secondary in 1999 to that in 2000?
Your response must be concise. 0.97. What is the ratio of the Expenditure(% of government expenditure on education) in Tertiary in 1999 to that in 2000?
Make the answer very short. 0.87. What is the ratio of the Expenditure(% of government expenditure on education) in Primary in 1999 to that in 2001?
Your answer should be very brief. 1.03. What is the ratio of the Expenditure(% of government expenditure on education) of Secondary in 1999 to that in 2001?
Your answer should be compact. 0.81. What is the ratio of the Expenditure(% of government expenditure on education) in Tertiary in 1999 to that in 2001?
Your answer should be very brief. 1.42. What is the ratio of the Expenditure(% of government expenditure on education) in Primary in 1999 to that in 2002?
Your answer should be very brief. 0.88. What is the ratio of the Expenditure(% of government expenditure on education) in Secondary in 1999 to that in 2002?
Your response must be concise. 0.87. What is the ratio of the Expenditure(% of government expenditure on education) in Tertiary in 1999 to that in 2002?
Make the answer very short. 1.43. What is the ratio of the Expenditure(% of government expenditure on education) in Primary in 1999 to that in 2003?
Make the answer very short. 1.04. What is the ratio of the Expenditure(% of government expenditure on education) of Secondary in 1999 to that in 2003?
Offer a very short reply. 0.65. What is the ratio of the Expenditure(% of government expenditure on education) in Tertiary in 1999 to that in 2003?
Ensure brevity in your answer.  1.26. What is the ratio of the Expenditure(% of government expenditure on education) in Primary in 1999 to that in 2004?
Your answer should be very brief. 0.88. What is the ratio of the Expenditure(% of government expenditure on education) of Secondary in 1999 to that in 2004?
Your answer should be very brief. 0.96. What is the ratio of the Expenditure(% of government expenditure on education) of Tertiary in 1999 to that in 2004?
Your answer should be very brief. 1.2. What is the ratio of the Expenditure(% of government expenditure on education) of Primary in 1999 to that in 2005?
Provide a succinct answer. 0.83. What is the ratio of the Expenditure(% of government expenditure on education) of Secondary in 1999 to that in 2005?
Give a very brief answer. 0.77. What is the ratio of the Expenditure(% of government expenditure on education) of Tertiary in 1999 to that in 2005?
Provide a short and direct response. 1.34. What is the ratio of the Expenditure(% of government expenditure on education) of Primary in 1999 to that in 2006?
Keep it short and to the point. 0.85. What is the ratio of the Expenditure(% of government expenditure on education) in Secondary in 1999 to that in 2006?
Offer a terse response. 0.85. What is the ratio of the Expenditure(% of government expenditure on education) in Tertiary in 1999 to that in 2006?
Ensure brevity in your answer.  1.5. What is the ratio of the Expenditure(% of government expenditure on education) in Primary in 1999 to that in 2008?
Offer a very short reply. 0.99. What is the ratio of the Expenditure(% of government expenditure on education) in Secondary in 1999 to that in 2008?
Provide a short and direct response. 0.8. What is the ratio of the Expenditure(% of government expenditure on education) in Tertiary in 1999 to that in 2008?
Give a very brief answer. 1.49. What is the ratio of the Expenditure(% of government expenditure on education) of Primary in 2000 to that in 2001?
Ensure brevity in your answer.  1.1. What is the ratio of the Expenditure(% of government expenditure on education) in Secondary in 2000 to that in 2001?
Ensure brevity in your answer.  0.83. What is the ratio of the Expenditure(% of government expenditure on education) in Tertiary in 2000 to that in 2001?
Offer a terse response. 1.63. What is the ratio of the Expenditure(% of government expenditure on education) in Primary in 2000 to that in 2002?
Keep it short and to the point. 0.94. What is the ratio of the Expenditure(% of government expenditure on education) of Secondary in 2000 to that in 2002?
Offer a terse response. 0.9. What is the ratio of the Expenditure(% of government expenditure on education) in Tertiary in 2000 to that in 2002?
Keep it short and to the point. 1.64. What is the ratio of the Expenditure(% of government expenditure on education) in Primary in 2000 to that in 2003?
Your response must be concise. 1.11. What is the ratio of the Expenditure(% of government expenditure on education) in Secondary in 2000 to that in 2003?
Ensure brevity in your answer.  0.68. What is the ratio of the Expenditure(% of government expenditure on education) in Tertiary in 2000 to that in 2003?
Provide a short and direct response. 1.44. What is the ratio of the Expenditure(% of government expenditure on education) in Primary in 2000 to that in 2004?
Offer a terse response. 0.94. What is the ratio of the Expenditure(% of government expenditure on education) in Secondary in 2000 to that in 2004?
Your answer should be very brief. 0.99. What is the ratio of the Expenditure(% of government expenditure on education) in Tertiary in 2000 to that in 2004?
Offer a terse response. 1.38. What is the ratio of the Expenditure(% of government expenditure on education) in Primary in 2000 to that in 2005?
Ensure brevity in your answer.  0.89. What is the ratio of the Expenditure(% of government expenditure on education) in Secondary in 2000 to that in 2005?
Give a very brief answer. 0.8. What is the ratio of the Expenditure(% of government expenditure on education) of Tertiary in 2000 to that in 2005?
Offer a terse response. 1.54. What is the ratio of the Expenditure(% of government expenditure on education) in Primary in 2000 to that in 2006?
Provide a short and direct response. 0.91. What is the ratio of the Expenditure(% of government expenditure on education) of Secondary in 2000 to that in 2006?
Provide a succinct answer. 0.88. What is the ratio of the Expenditure(% of government expenditure on education) in Tertiary in 2000 to that in 2006?
Your answer should be very brief. 1.72. What is the ratio of the Expenditure(% of government expenditure on education) of Primary in 2000 to that in 2008?
Offer a terse response. 1.05. What is the ratio of the Expenditure(% of government expenditure on education) of Secondary in 2000 to that in 2008?
Make the answer very short. 0.83. What is the ratio of the Expenditure(% of government expenditure on education) of Tertiary in 2000 to that in 2008?
Your response must be concise. 1.71. What is the ratio of the Expenditure(% of government expenditure on education) of Primary in 2001 to that in 2002?
Provide a short and direct response. 0.85. What is the ratio of the Expenditure(% of government expenditure on education) in Secondary in 2001 to that in 2002?
Your response must be concise. 1.07. What is the ratio of the Expenditure(% of government expenditure on education) in Primary in 2001 to that in 2003?
Make the answer very short. 1.01. What is the ratio of the Expenditure(% of government expenditure on education) of Secondary in 2001 to that in 2003?
Provide a succinct answer. 0.81. What is the ratio of the Expenditure(% of government expenditure on education) of Tertiary in 2001 to that in 2003?
Your answer should be very brief. 0.88. What is the ratio of the Expenditure(% of government expenditure on education) of Primary in 2001 to that in 2004?
Keep it short and to the point. 0.85. What is the ratio of the Expenditure(% of government expenditure on education) of Secondary in 2001 to that in 2004?
Give a very brief answer. 1.19. What is the ratio of the Expenditure(% of government expenditure on education) of Tertiary in 2001 to that in 2004?
Your answer should be compact. 0.85. What is the ratio of the Expenditure(% of government expenditure on education) of Primary in 2001 to that in 2005?
Your answer should be compact. 0.81. What is the ratio of the Expenditure(% of government expenditure on education) in Secondary in 2001 to that in 2005?
Keep it short and to the point. 0.95. What is the ratio of the Expenditure(% of government expenditure on education) of Tertiary in 2001 to that in 2005?
Provide a short and direct response. 0.94. What is the ratio of the Expenditure(% of government expenditure on education) of Primary in 2001 to that in 2006?
Provide a short and direct response. 0.82. What is the ratio of the Expenditure(% of government expenditure on education) of Secondary in 2001 to that in 2006?
Your answer should be compact. 1.06. What is the ratio of the Expenditure(% of government expenditure on education) in Tertiary in 2001 to that in 2006?
Make the answer very short. 1.06. What is the ratio of the Expenditure(% of government expenditure on education) in Primary in 2001 to that in 2008?
Your answer should be compact. 0.95. What is the ratio of the Expenditure(% of government expenditure on education) in Secondary in 2001 to that in 2008?
Your answer should be compact. 0.99. What is the ratio of the Expenditure(% of government expenditure on education) of Tertiary in 2001 to that in 2008?
Your answer should be very brief. 1.05. What is the ratio of the Expenditure(% of government expenditure on education) in Primary in 2002 to that in 2003?
Offer a terse response. 1.19. What is the ratio of the Expenditure(% of government expenditure on education) of Secondary in 2002 to that in 2003?
Provide a succinct answer. 0.76. What is the ratio of the Expenditure(% of government expenditure on education) in Tertiary in 2002 to that in 2003?
Your response must be concise. 0.88. What is the ratio of the Expenditure(% of government expenditure on education) of Secondary in 2002 to that in 2004?
Your response must be concise. 1.11. What is the ratio of the Expenditure(% of government expenditure on education) of Tertiary in 2002 to that in 2004?
Provide a short and direct response. 0.84. What is the ratio of the Expenditure(% of government expenditure on education) of Primary in 2002 to that in 2005?
Provide a short and direct response. 0.94. What is the ratio of the Expenditure(% of government expenditure on education) of Secondary in 2002 to that in 2005?
Your answer should be very brief. 0.89. What is the ratio of the Expenditure(% of government expenditure on education) of Primary in 2002 to that in 2006?
Your answer should be compact. 0.97. What is the ratio of the Expenditure(% of government expenditure on education) in Secondary in 2002 to that in 2006?
Your answer should be very brief. 0.99. What is the ratio of the Expenditure(% of government expenditure on education) in Tertiary in 2002 to that in 2006?
Offer a terse response. 1.05. What is the ratio of the Expenditure(% of government expenditure on education) in Primary in 2002 to that in 2008?
Make the answer very short. 1.12. What is the ratio of the Expenditure(% of government expenditure on education) of Secondary in 2002 to that in 2008?
Provide a succinct answer. 0.93. What is the ratio of the Expenditure(% of government expenditure on education) of Tertiary in 2002 to that in 2008?
Give a very brief answer. 1.04. What is the ratio of the Expenditure(% of government expenditure on education) in Primary in 2003 to that in 2004?
Keep it short and to the point. 0.84. What is the ratio of the Expenditure(% of government expenditure on education) of Secondary in 2003 to that in 2004?
Keep it short and to the point. 1.47. What is the ratio of the Expenditure(% of government expenditure on education) in Tertiary in 2003 to that in 2004?
Provide a short and direct response. 0.96. What is the ratio of the Expenditure(% of government expenditure on education) in Primary in 2003 to that in 2005?
Your answer should be very brief. 0.8. What is the ratio of the Expenditure(% of government expenditure on education) in Secondary in 2003 to that in 2005?
Your response must be concise. 1.18. What is the ratio of the Expenditure(% of government expenditure on education) of Tertiary in 2003 to that in 2005?
Your answer should be compact. 1.07. What is the ratio of the Expenditure(% of government expenditure on education) in Primary in 2003 to that in 2006?
Your answer should be very brief. 0.81. What is the ratio of the Expenditure(% of government expenditure on education) of Secondary in 2003 to that in 2006?
Your answer should be very brief. 1.3. What is the ratio of the Expenditure(% of government expenditure on education) in Tertiary in 2003 to that in 2006?
Provide a succinct answer. 1.2. What is the ratio of the Expenditure(% of government expenditure on education) in Primary in 2003 to that in 2008?
Make the answer very short. 0.94. What is the ratio of the Expenditure(% of government expenditure on education) of Secondary in 2003 to that in 2008?
Your answer should be compact. 1.23. What is the ratio of the Expenditure(% of government expenditure on education) in Tertiary in 2003 to that in 2008?
Make the answer very short. 1.18. What is the ratio of the Expenditure(% of government expenditure on education) of Primary in 2004 to that in 2005?
Offer a terse response. 0.94. What is the ratio of the Expenditure(% of government expenditure on education) of Secondary in 2004 to that in 2005?
Provide a short and direct response. 0.8. What is the ratio of the Expenditure(% of government expenditure on education) of Tertiary in 2004 to that in 2005?
Your response must be concise. 1.11. What is the ratio of the Expenditure(% of government expenditure on education) in Primary in 2004 to that in 2006?
Offer a terse response. 0.97. What is the ratio of the Expenditure(% of government expenditure on education) in Secondary in 2004 to that in 2006?
Your response must be concise. 0.89. What is the ratio of the Expenditure(% of government expenditure on education) of Tertiary in 2004 to that in 2006?
Your answer should be very brief. 1.25. What is the ratio of the Expenditure(% of government expenditure on education) in Primary in 2004 to that in 2008?
Make the answer very short. 1.12. What is the ratio of the Expenditure(% of government expenditure on education) of Secondary in 2004 to that in 2008?
Make the answer very short. 0.84. What is the ratio of the Expenditure(% of government expenditure on education) of Tertiary in 2004 to that in 2008?
Provide a succinct answer. 1.24. What is the ratio of the Expenditure(% of government expenditure on education) of Primary in 2005 to that in 2006?
Your response must be concise. 1.02. What is the ratio of the Expenditure(% of government expenditure on education) in Secondary in 2005 to that in 2006?
Make the answer very short. 1.11. What is the ratio of the Expenditure(% of government expenditure on education) in Tertiary in 2005 to that in 2006?
Your answer should be compact. 1.12. What is the ratio of the Expenditure(% of government expenditure on education) of Primary in 2005 to that in 2008?
Offer a very short reply. 1.19. What is the ratio of the Expenditure(% of government expenditure on education) of Secondary in 2005 to that in 2008?
Make the answer very short. 1.04. What is the ratio of the Expenditure(% of government expenditure on education) of Tertiary in 2005 to that in 2008?
Your answer should be compact. 1.11. What is the ratio of the Expenditure(% of government expenditure on education) in Primary in 2006 to that in 2008?
Provide a short and direct response. 1.16. What is the ratio of the Expenditure(% of government expenditure on education) in Secondary in 2006 to that in 2008?
Keep it short and to the point. 0.94. What is the ratio of the Expenditure(% of government expenditure on education) of Tertiary in 2006 to that in 2008?
Your answer should be very brief. 0.99. What is the difference between the highest and the second highest Expenditure(% of government expenditure on education) in Primary?
Your answer should be compact. 0.87. What is the difference between the highest and the second highest Expenditure(% of government expenditure on education) in Secondary?
Your answer should be compact. 6.18. What is the difference between the highest and the second highest Expenditure(% of government expenditure on education) in Tertiary?
Your answer should be very brief. 4.68. What is the difference between the highest and the lowest Expenditure(% of government expenditure on education) in Primary?
Ensure brevity in your answer.  8.11. What is the difference between the highest and the lowest Expenditure(% of government expenditure on education) in Secondary?
Your response must be concise. 14.2. What is the difference between the highest and the lowest Expenditure(% of government expenditure on education) of Tertiary?
Provide a short and direct response. 15.44. 